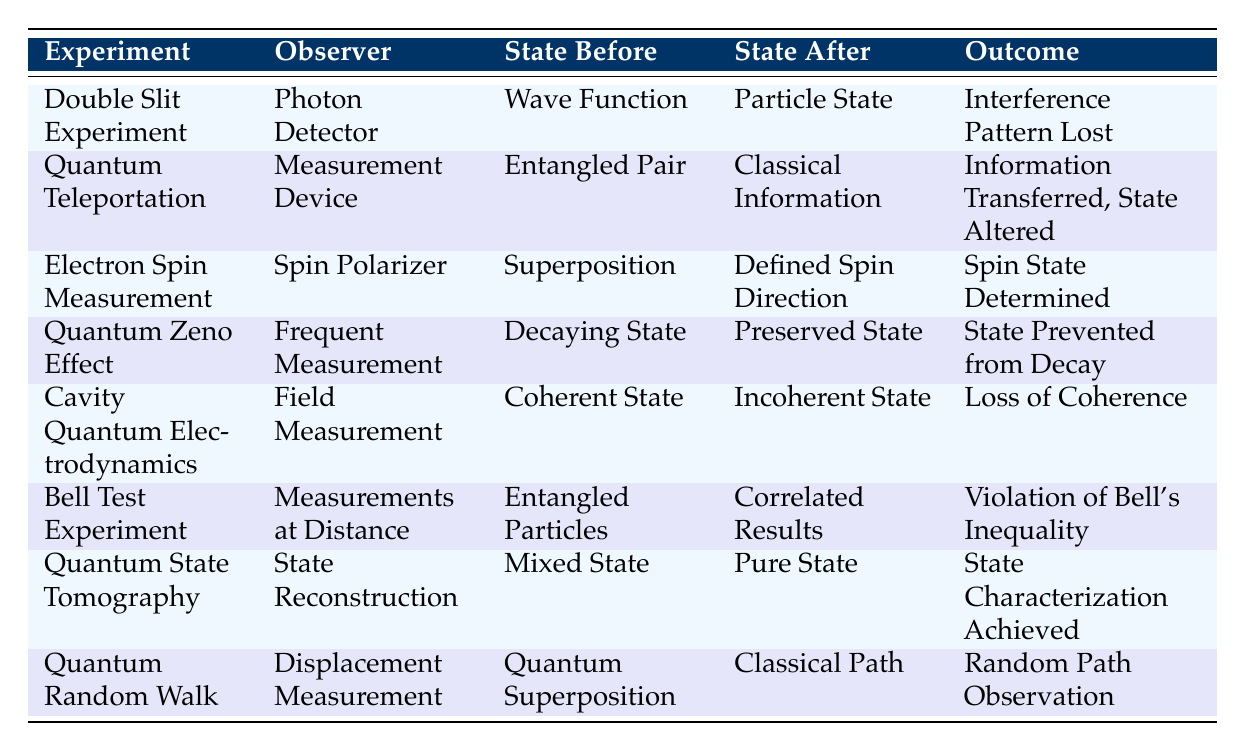What is the outcome of the Double Slit Experiment? Looking at the table, the row for the Double Slit Experiment states that the outcome is "Interference Pattern Lost."
Answer: Interference Pattern Lost Which observer is involved in Quantum Teleportation? In the table, the row for Quantum Teleportation lists "Measurement Device" as the observer.
Answer: Measurement Device How many experiments resulted in a loss of coherence? By examining the table, only one experiment, "Cavity Quantum Electrodynamics," mentions the outcome as "Loss of Coherence." Therefore, the count is one.
Answer: 1 Is the outcome of the Electron Spin Measurement a determined spin state? The table states that for the Electron Spin Measurement, the outcome is "Spin State Determined," which confirms that it is indeed a determined spin state.
Answer: Yes What state do particles remain in after frequent measurements according to the Quantum Zeno Effect? The Quantum Zeno Effect row states that the state before observation is "Decaying State," and after observation, it is "Preserved State," showing consistency in the particles' state.
Answer: Preserved State How many experiments involve entangled particles and what are their outcomes? In the table, there are two entries that mention entangled particles: "Quantum Teleportation" which has the outcome "Information Transferred, State Altered," and "Bell Test Experiment" which results in "Violation of Bell's Inequality." Therefore, there are a total of two experiments.
Answer: 2 In how many experiments does the quantum state change from a superposition to a defined state? The table indicates that the Electron Spin Measurement changes from "Superposition" to "Defined Spin Direction," giving us one example of this change.
Answer: 1 What is the quantum state before observation in a Quantum Random Walk? According to the table, the quantum state before observation in the Quantum Random Walk experiment is described as "Quantum Superposition."
Answer: Quantum Superposition Which experiment has the outcome of state characterization achieved? In the table, the "Quantum State Tomography" experiment is noted as having the outcome "State Characterization Achieved."
Answer: Quantum State Tomography 